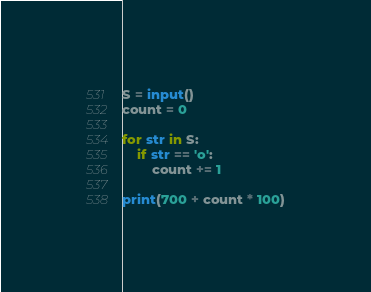Convert code to text. <code><loc_0><loc_0><loc_500><loc_500><_Python_>S = input()
count = 0

for str in S:
    if str == 'o':
        count += 1

print(700 + count * 100)
</code> 